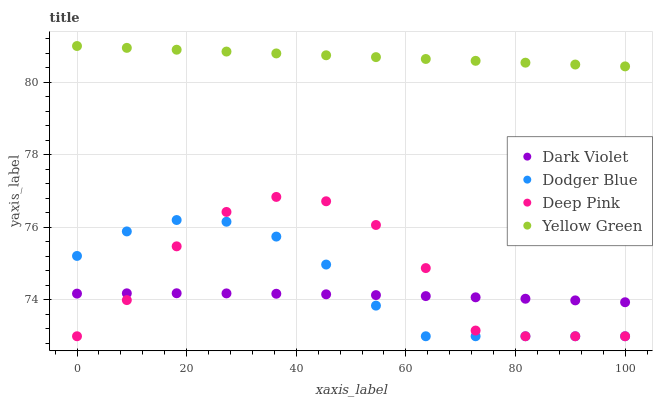Does Dark Violet have the minimum area under the curve?
Answer yes or no. Yes. Does Yellow Green have the maximum area under the curve?
Answer yes or no. Yes. Does Dodger Blue have the minimum area under the curve?
Answer yes or no. No. Does Dodger Blue have the maximum area under the curve?
Answer yes or no. No. Is Yellow Green the smoothest?
Answer yes or no. Yes. Is Deep Pink the roughest?
Answer yes or no. Yes. Is Dodger Blue the smoothest?
Answer yes or no. No. Is Dodger Blue the roughest?
Answer yes or no. No. Does Deep Pink have the lowest value?
Answer yes or no. Yes. Does Yellow Green have the lowest value?
Answer yes or no. No. Does Yellow Green have the highest value?
Answer yes or no. Yes. Does Dodger Blue have the highest value?
Answer yes or no. No. Is Dodger Blue less than Yellow Green?
Answer yes or no. Yes. Is Yellow Green greater than Deep Pink?
Answer yes or no. Yes. Does Dodger Blue intersect Deep Pink?
Answer yes or no. Yes. Is Dodger Blue less than Deep Pink?
Answer yes or no. No. Is Dodger Blue greater than Deep Pink?
Answer yes or no. No. Does Dodger Blue intersect Yellow Green?
Answer yes or no. No. 